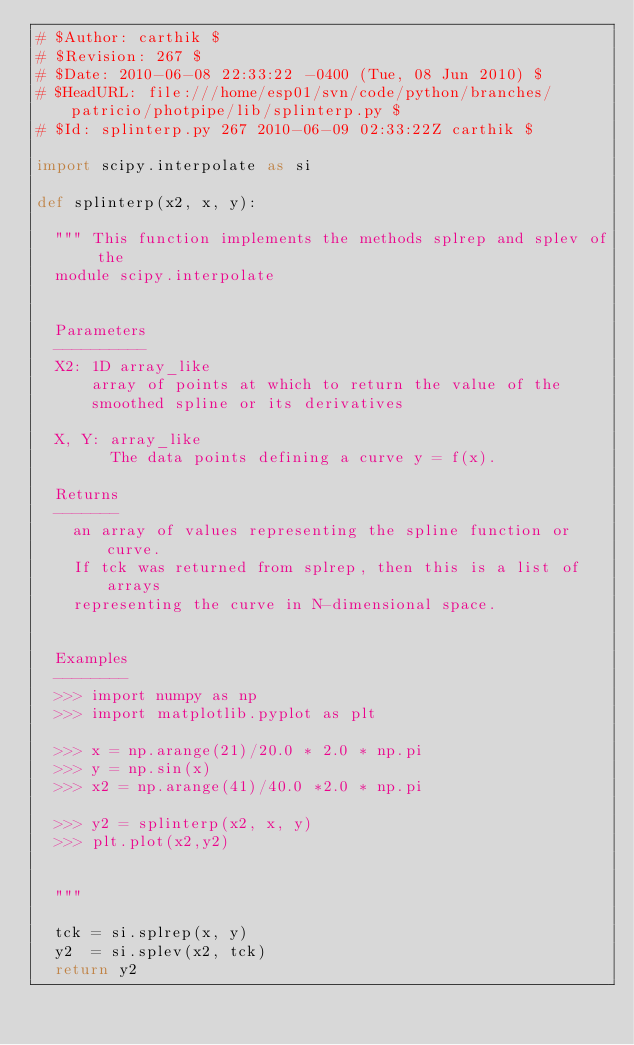Convert code to text. <code><loc_0><loc_0><loc_500><loc_500><_Python_># $Author: carthik $
# $Revision: 267 $
# $Date: 2010-06-08 22:33:22 -0400 (Tue, 08 Jun 2010) $
# $HeadURL: file:///home/esp01/svn/code/python/branches/patricio/photpipe/lib/splinterp.py $
# $Id: splinterp.py 267 2010-06-09 02:33:22Z carthik $

import scipy.interpolate as si

def splinterp(x2, x, y):

  """ This function implements the methods splrep and splev of the
  module scipy.interpolate
 

  Parameters
  ----------
  X2: 1D array_like
      array of points at which to return the value of the
      smoothed spline or its derivatives

  X, Y: array_like
        The data points defining a curve y = f(x).

  Returns 
  ------- 
    an array of values representing the spline function or curve.
    If tck was returned from splrep, then this is a list of arrays
    representing the curve in N-dimensional space.


  Examples
  --------
  >>> import numpy as np
  >>> import matplotlib.pyplot as plt

  >>> x = np.arange(21)/20.0 * 2.0 * np.pi 
  >>> y = np.sin(x)
  >>> x2 = np.arange(41)/40.0 *2.0 * np.pi

  >>> y2 = splinterp(x2, x, y)
  >>> plt.plot(x2,y2)


  """

  tck = si.splrep(x, y)
  y2  = si.splev(x2, tck)
  return y2
  </code> 